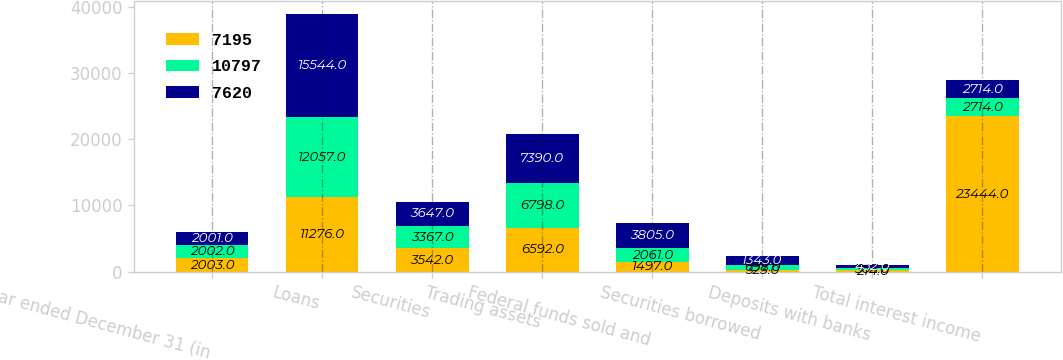Convert chart to OTSL. <chart><loc_0><loc_0><loc_500><loc_500><stacked_bar_chart><ecel><fcel>Year ended December 31 (in<fcel>Loans<fcel>Securities<fcel>Trading assets<fcel>Federal funds sold and<fcel>Securities borrowed<fcel>Deposits with banks<fcel>Total interest income<nl><fcel>7195<fcel>2003<fcel>11276<fcel>3542<fcel>6592<fcel>1497<fcel>323<fcel>214<fcel>23444<nl><fcel>10797<fcel>2002<fcel>12057<fcel>3367<fcel>6798<fcel>2061<fcel>698<fcel>303<fcel>2714<nl><fcel>7620<fcel>2001<fcel>15544<fcel>3647<fcel>7390<fcel>3805<fcel>1343<fcel>452<fcel>2714<nl></chart> 